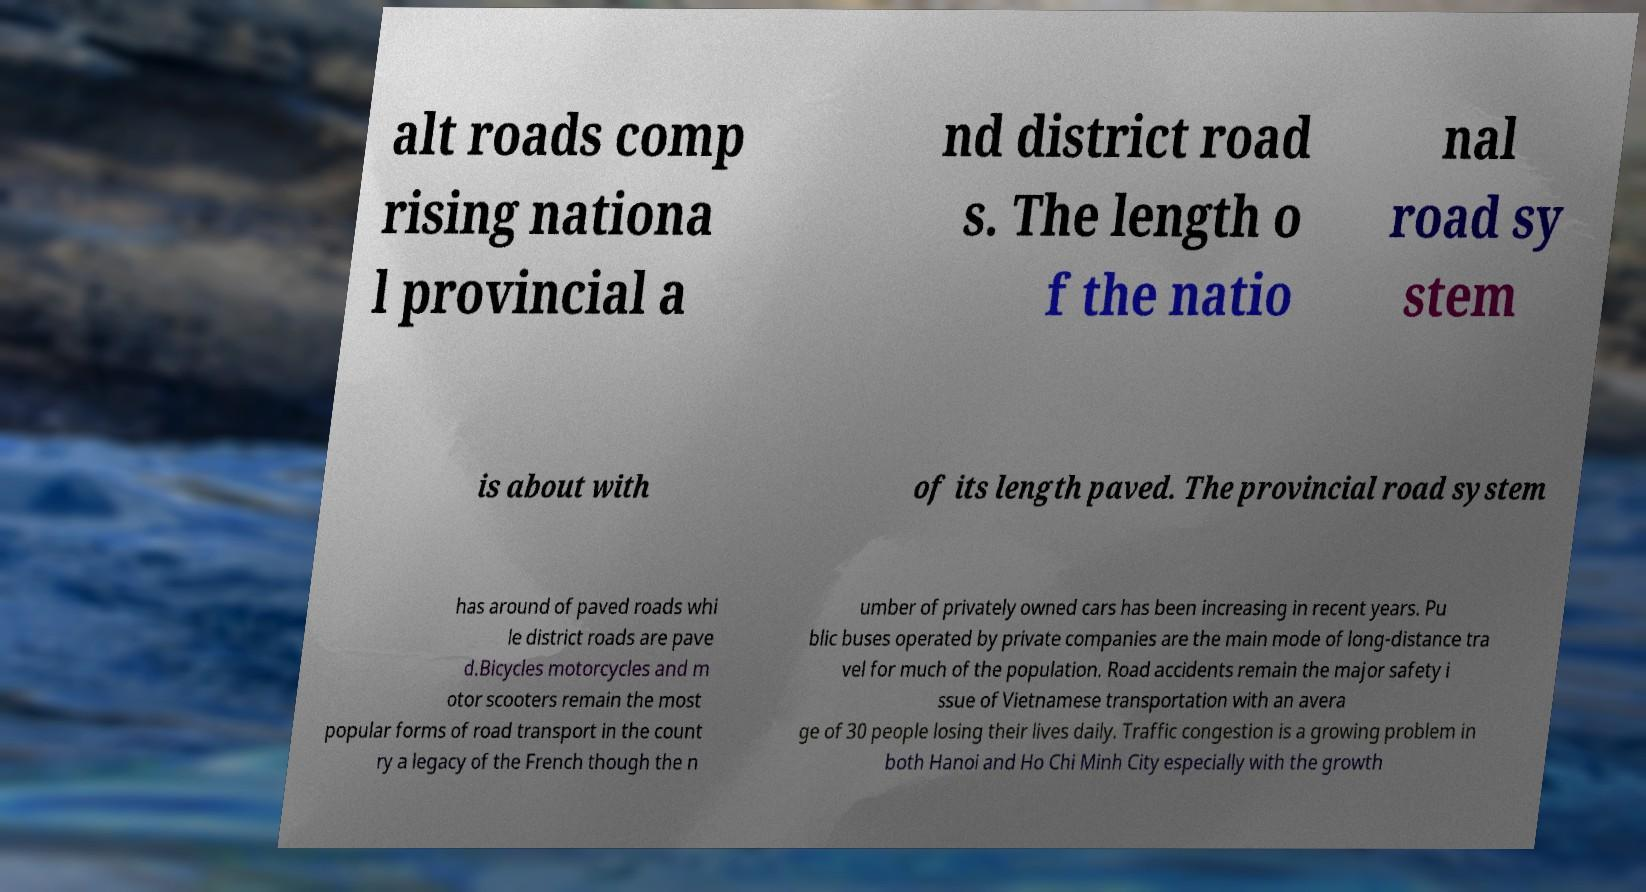There's text embedded in this image that I need extracted. Can you transcribe it verbatim? alt roads comp rising nationa l provincial a nd district road s. The length o f the natio nal road sy stem is about with of its length paved. The provincial road system has around of paved roads whi le district roads are pave d.Bicycles motorcycles and m otor scooters remain the most popular forms of road transport in the count ry a legacy of the French though the n umber of privately owned cars has been increasing in recent years. Pu blic buses operated by private companies are the main mode of long-distance tra vel for much of the population. Road accidents remain the major safety i ssue of Vietnamese transportation with an avera ge of 30 people losing their lives daily. Traffic congestion is a growing problem in both Hanoi and Ho Chi Minh City especially with the growth 